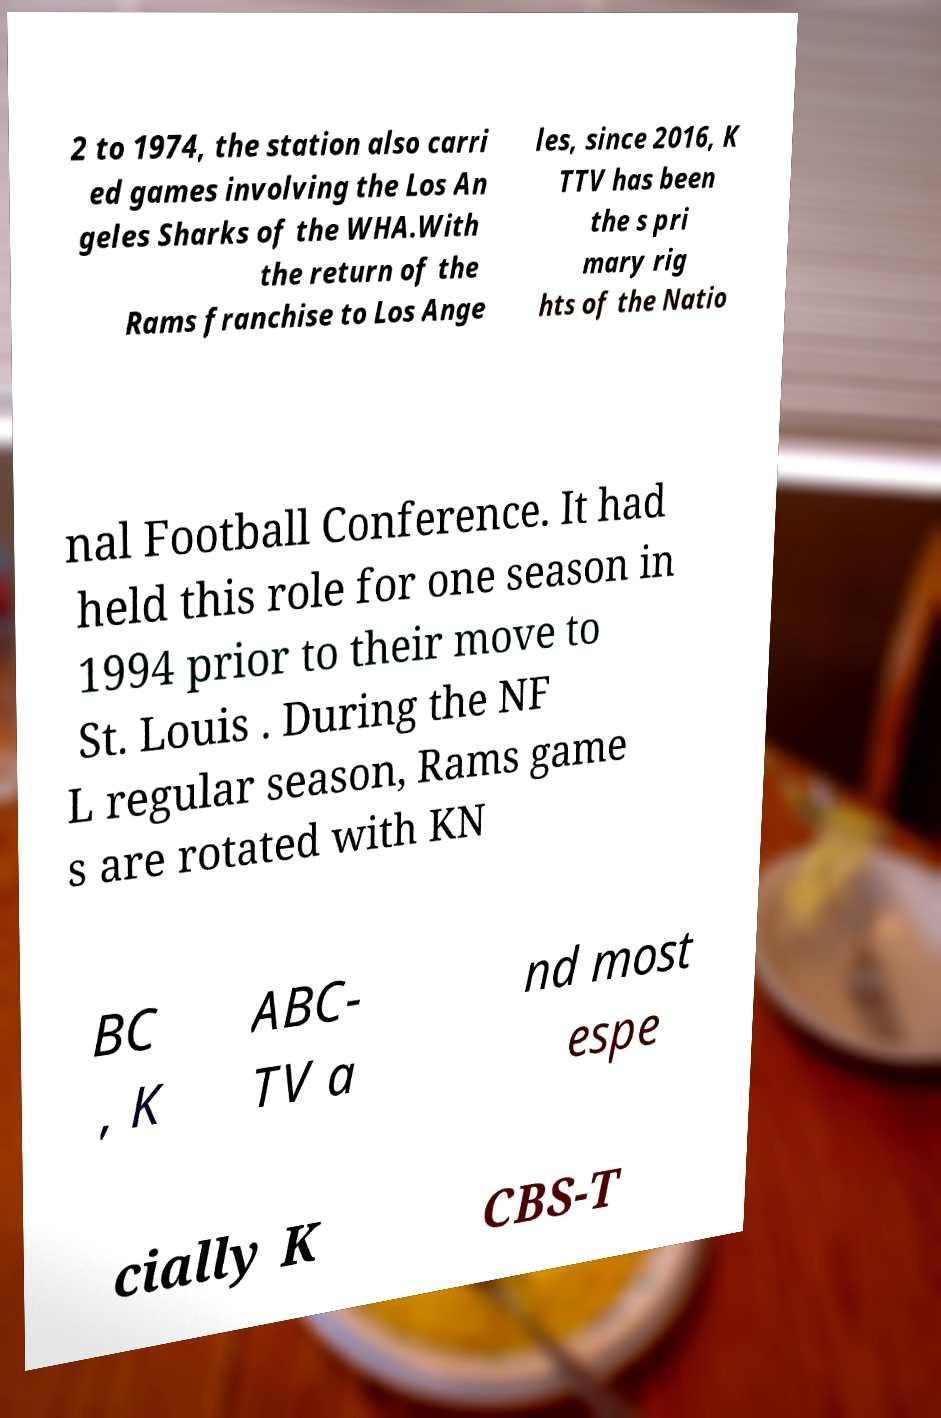Could you assist in decoding the text presented in this image and type it out clearly? 2 to 1974, the station also carri ed games involving the Los An geles Sharks of the WHA.With the return of the Rams franchise to Los Ange les, since 2016, K TTV has been the s pri mary rig hts of the Natio nal Football Conference. It had held this role for one season in 1994 prior to their move to St. Louis . During the NF L regular season, Rams game s are rotated with KN BC , K ABC- TV a nd most espe cially K CBS-T 